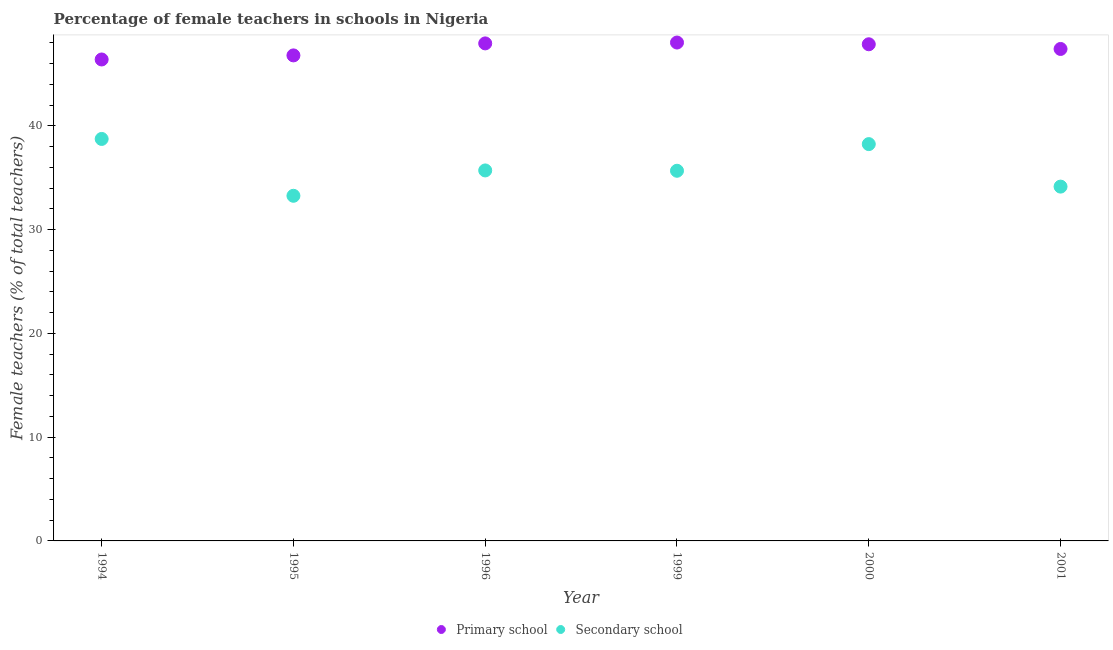How many different coloured dotlines are there?
Offer a very short reply. 2. What is the percentage of female teachers in primary schools in 1999?
Offer a terse response. 48.02. Across all years, what is the maximum percentage of female teachers in primary schools?
Your answer should be compact. 48.02. Across all years, what is the minimum percentage of female teachers in secondary schools?
Your answer should be very brief. 33.26. In which year was the percentage of female teachers in primary schools minimum?
Provide a short and direct response. 1994. What is the total percentage of female teachers in secondary schools in the graph?
Give a very brief answer. 215.74. What is the difference between the percentage of female teachers in secondary schools in 1995 and that in 2001?
Your response must be concise. -0.88. What is the difference between the percentage of female teachers in primary schools in 1999 and the percentage of female teachers in secondary schools in 2000?
Offer a very short reply. 9.79. What is the average percentage of female teachers in primary schools per year?
Your response must be concise. 47.4. In the year 2001, what is the difference between the percentage of female teachers in primary schools and percentage of female teachers in secondary schools?
Offer a terse response. 13.26. In how many years, is the percentage of female teachers in secondary schools greater than 2 %?
Keep it short and to the point. 6. What is the ratio of the percentage of female teachers in secondary schools in 1994 to that in 2000?
Ensure brevity in your answer.  1.01. Is the difference between the percentage of female teachers in primary schools in 1994 and 1995 greater than the difference between the percentage of female teachers in secondary schools in 1994 and 1995?
Your response must be concise. No. What is the difference between the highest and the second highest percentage of female teachers in secondary schools?
Offer a very short reply. 0.5. What is the difference between the highest and the lowest percentage of female teachers in primary schools?
Make the answer very short. 1.63. Is the sum of the percentage of female teachers in secondary schools in 1994 and 1995 greater than the maximum percentage of female teachers in primary schools across all years?
Provide a succinct answer. Yes. Does the percentage of female teachers in secondary schools monotonically increase over the years?
Provide a short and direct response. No. Is the percentage of female teachers in secondary schools strictly greater than the percentage of female teachers in primary schools over the years?
Offer a terse response. No. Is the percentage of female teachers in secondary schools strictly less than the percentage of female teachers in primary schools over the years?
Your answer should be compact. Yes. How many dotlines are there?
Your answer should be very brief. 2. What is the difference between two consecutive major ticks on the Y-axis?
Offer a very short reply. 10. Are the values on the major ticks of Y-axis written in scientific E-notation?
Offer a terse response. No. Does the graph contain any zero values?
Provide a succinct answer. No. Does the graph contain grids?
Keep it short and to the point. No. Where does the legend appear in the graph?
Make the answer very short. Bottom center. What is the title of the graph?
Give a very brief answer. Percentage of female teachers in schools in Nigeria. What is the label or title of the X-axis?
Your response must be concise. Year. What is the label or title of the Y-axis?
Provide a succinct answer. Female teachers (% of total teachers). What is the Female teachers (% of total teachers) of Primary school in 1994?
Make the answer very short. 46.39. What is the Female teachers (% of total teachers) of Secondary school in 1994?
Keep it short and to the point. 38.74. What is the Female teachers (% of total teachers) in Primary school in 1995?
Make the answer very short. 46.79. What is the Female teachers (% of total teachers) in Secondary school in 1995?
Offer a terse response. 33.26. What is the Female teachers (% of total teachers) in Primary school in 1996?
Offer a very short reply. 47.94. What is the Female teachers (% of total teachers) in Secondary school in 1996?
Give a very brief answer. 35.7. What is the Female teachers (% of total teachers) of Primary school in 1999?
Ensure brevity in your answer.  48.02. What is the Female teachers (% of total teachers) in Secondary school in 1999?
Offer a very short reply. 35.67. What is the Female teachers (% of total teachers) in Primary school in 2000?
Provide a short and direct response. 47.86. What is the Female teachers (% of total teachers) of Secondary school in 2000?
Provide a short and direct response. 38.24. What is the Female teachers (% of total teachers) in Primary school in 2001?
Give a very brief answer. 47.41. What is the Female teachers (% of total teachers) of Secondary school in 2001?
Provide a succinct answer. 34.14. Across all years, what is the maximum Female teachers (% of total teachers) in Primary school?
Ensure brevity in your answer.  48.02. Across all years, what is the maximum Female teachers (% of total teachers) in Secondary school?
Make the answer very short. 38.74. Across all years, what is the minimum Female teachers (% of total teachers) in Primary school?
Offer a terse response. 46.39. Across all years, what is the minimum Female teachers (% of total teachers) in Secondary school?
Offer a terse response. 33.26. What is the total Female teachers (% of total teachers) of Primary school in the graph?
Make the answer very short. 284.41. What is the total Female teachers (% of total teachers) in Secondary school in the graph?
Make the answer very short. 215.74. What is the difference between the Female teachers (% of total teachers) of Primary school in 1994 and that in 1995?
Keep it short and to the point. -0.39. What is the difference between the Female teachers (% of total teachers) in Secondary school in 1994 and that in 1995?
Your response must be concise. 5.48. What is the difference between the Female teachers (% of total teachers) of Primary school in 1994 and that in 1996?
Keep it short and to the point. -1.55. What is the difference between the Female teachers (% of total teachers) of Secondary school in 1994 and that in 1996?
Your answer should be compact. 3.03. What is the difference between the Female teachers (% of total teachers) of Primary school in 1994 and that in 1999?
Your answer should be compact. -1.63. What is the difference between the Female teachers (% of total teachers) of Secondary school in 1994 and that in 1999?
Offer a terse response. 3.07. What is the difference between the Female teachers (% of total teachers) in Primary school in 1994 and that in 2000?
Keep it short and to the point. -1.47. What is the difference between the Female teachers (% of total teachers) in Secondary school in 1994 and that in 2000?
Offer a very short reply. 0.5. What is the difference between the Female teachers (% of total teachers) in Primary school in 1994 and that in 2001?
Provide a short and direct response. -1.01. What is the difference between the Female teachers (% of total teachers) of Secondary school in 1994 and that in 2001?
Your answer should be compact. 4.59. What is the difference between the Female teachers (% of total teachers) of Primary school in 1995 and that in 1996?
Keep it short and to the point. -1.16. What is the difference between the Female teachers (% of total teachers) in Secondary school in 1995 and that in 1996?
Your response must be concise. -2.44. What is the difference between the Female teachers (% of total teachers) in Primary school in 1995 and that in 1999?
Offer a very short reply. -1.24. What is the difference between the Female teachers (% of total teachers) of Secondary school in 1995 and that in 1999?
Provide a short and direct response. -2.41. What is the difference between the Female teachers (% of total teachers) of Primary school in 1995 and that in 2000?
Keep it short and to the point. -1.07. What is the difference between the Female teachers (% of total teachers) in Secondary school in 1995 and that in 2000?
Provide a succinct answer. -4.98. What is the difference between the Female teachers (% of total teachers) in Primary school in 1995 and that in 2001?
Your answer should be very brief. -0.62. What is the difference between the Female teachers (% of total teachers) of Secondary school in 1995 and that in 2001?
Ensure brevity in your answer.  -0.88. What is the difference between the Female teachers (% of total teachers) in Primary school in 1996 and that in 1999?
Make the answer very short. -0.08. What is the difference between the Female teachers (% of total teachers) of Secondary school in 1996 and that in 1999?
Provide a short and direct response. 0.03. What is the difference between the Female teachers (% of total teachers) in Primary school in 1996 and that in 2000?
Your response must be concise. 0.08. What is the difference between the Female teachers (% of total teachers) of Secondary school in 1996 and that in 2000?
Your response must be concise. -2.54. What is the difference between the Female teachers (% of total teachers) in Primary school in 1996 and that in 2001?
Provide a succinct answer. 0.54. What is the difference between the Female teachers (% of total teachers) in Secondary school in 1996 and that in 2001?
Offer a terse response. 1.56. What is the difference between the Female teachers (% of total teachers) in Primary school in 1999 and that in 2000?
Provide a succinct answer. 0.17. What is the difference between the Female teachers (% of total teachers) of Secondary school in 1999 and that in 2000?
Your answer should be very brief. -2.57. What is the difference between the Female teachers (% of total teachers) in Primary school in 1999 and that in 2001?
Give a very brief answer. 0.62. What is the difference between the Female teachers (% of total teachers) in Secondary school in 1999 and that in 2001?
Your response must be concise. 1.53. What is the difference between the Female teachers (% of total teachers) of Primary school in 2000 and that in 2001?
Your answer should be very brief. 0.45. What is the difference between the Female teachers (% of total teachers) in Secondary school in 2000 and that in 2001?
Keep it short and to the point. 4.1. What is the difference between the Female teachers (% of total teachers) in Primary school in 1994 and the Female teachers (% of total teachers) in Secondary school in 1995?
Your response must be concise. 13.14. What is the difference between the Female teachers (% of total teachers) in Primary school in 1994 and the Female teachers (% of total teachers) in Secondary school in 1996?
Provide a short and direct response. 10.69. What is the difference between the Female teachers (% of total teachers) in Primary school in 1994 and the Female teachers (% of total teachers) in Secondary school in 1999?
Keep it short and to the point. 10.72. What is the difference between the Female teachers (% of total teachers) in Primary school in 1994 and the Female teachers (% of total teachers) in Secondary school in 2000?
Your answer should be very brief. 8.16. What is the difference between the Female teachers (% of total teachers) in Primary school in 1994 and the Female teachers (% of total teachers) in Secondary school in 2001?
Offer a very short reply. 12.25. What is the difference between the Female teachers (% of total teachers) in Primary school in 1995 and the Female teachers (% of total teachers) in Secondary school in 1996?
Your answer should be very brief. 11.09. What is the difference between the Female teachers (% of total teachers) in Primary school in 1995 and the Female teachers (% of total teachers) in Secondary school in 1999?
Provide a short and direct response. 11.12. What is the difference between the Female teachers (% of total teachers) in Primary school in 1995 and the Female teachers (% of total teachers) in Secondary school in 2000?
Your answer should be very brief. 8.55. What is the difference between the Female teachers (% of total teachers) of Primary school in 1995 and the Female teachers (% of total teachers) of Secondary school in 2001?
Your response must be concise. 12.64. What is the difference between the Female teachers (% of total teachers) in Primary school in 1996 and the Female teachers (% of total teachers) in Secondary school in 1999?
Provide a succinct answer. 12.27. What is the difference between the Female teachers (% of total teachers) in Primary school in 1996 and the Female teachers (% of total teachers) in Secondary school in 2000?
Your answer should be very brief. 9.71. What is the difference between the Female teachers (% of total teachers) in Primary school in 1996 and the Female teachers (% of total teachers) in Secondary school in 2001?
Ensure brevity in your answer.  13.8. What is the difference between the Female teachers (% of total teachers) in Primary school in 1999 and the Female teachers (% of total teachers) in Secondary school in 2000?
Give a very brief answer. 9.79. What is the difference between the Female teachers (% of total teachers) of Primary school in 1999 and the Female teachers (% of total teachers) of Secondary school in 2001?
Your answer should be very brief. 13.88. What is the difference between the Female teachers (% of total teachers) of Primary school in 2000 and the Female teachers (% of total teachers) of Secondary school in 2001?
Your answer should be very brief. 13.72. What is the average Female teachers (% of total teachers) in Primary school per year?
Provide a succinct answer. 47.4. What is the average Female teachers (% of total teachers) of Secondary school per year?
Provide a succinct answer. 35.96. In the year 1994, what is the difference between the Female teachers (% of total teachers) in Primary school and Female teachers (% of total teachers) in Secondary school?
Your response must be concise. 7.66. In the year 1995, what is the difference between the Female teachers (% of total teachers) of Primary school and Female teachers (% of total teachers) of Secondary school?
Provide a succinct answer. 13.53. In the year 1996, what is the difference between the Female teachers (% of total teachers) of Primary school and Female teachers (% of total teachers) of Secondary school?
Keep it short and to the point. 12.24. In the year 1999, what is the difference between the Female teachers (% of total teachers) of Primary school and Female teachers (% of total teachers) of Secondary school?
Provide a short and direct response. 12.36. In the year 2000, what is the difference between the Female teachers (% of total teachers) of Primary school and Female teachers (% of total teachers) of Secondary school?
Make the answer very short. 9.62. In the year 2001, what is the difference between the Female teachers (% of total teachers) of Primary school and Female teachers (% of total teachers) of Secondary school?
Offer a very short reply. 13.26. What is the ratio of the Female teachers (% of total teachers) in Primary school in 1994 to that in 1995?
Your response must be concise. 0.99. What is the ratio of the Female teachers (% of total teachers) of Secondary school in 1994 to that in 1995?
Your answer should be very brief. 1.16. What is the ratio of the Female teachers (% of total teachers) in Secondary school in 1994 to that in 1996?
Give a very brief answer. 1.08. What is the ratio of the Female teachers (% of total teachers) of Secondary school in 1994 to that in 1999?
Ensure brevity in your answer.  1.09. What is the ratio of the Female teachers (% of total teachers) in Primary school in 1994 to that in 2000?
Offer a very short reply. 0.97. What is the ratio of the Female teachers (% of total teachers) in Primary school in 1994 to that in 2001?
Keep it short and to the point. 0.98. What is the ratio of the Female teachers (% of total teachers) in Secondary school in 1994 to that in 2001?
Offer a very short reply. 1.13. What is the ratio of the Female teachers (% of total teachers) in Primary school in 1995 to that in 1996?
Keep it short and to the point. 0.98. What is the ratio of the Female teachers (% of total teachers) of Secondary school in 1995 to that in 1996?
Your answer should be compact. 0.93. What is the ratio of the Female teachers (% of total teachers) of Primary school in 1995 to that in 1999?
Provide a succinct answer. 0.97. What is the ratio of the Female teachers (% of total teachers) of Secondary school in 1995 to that in 1999?
Give a very brief answer. 0.93. What is the ratio of the Female teachers (% of total teachers) of Primary school in 1995 to that in 2000?
Your answer should be very brief. 0.98. What is the ratio of the Female teachers (% of total teachers) in Secondary school in 1995 to that in 2000?
Your response must be concise. 0.87. What is the ratio of the Female teachers (% of total teachers) in Primary school in 1995 to that in 2001?
Keep it short and to the point. 0.99. What is the ratio of the Female teachers (% of total teachers) in Secondary school in 1995 to that in 2001?
Give a very brief answer. 0.97. What is the ratio of the Female teachers (% of total teachers) of Secondary school in 1996 to that in 1999?
Make the answer very short. 1. What is the ratio of the Female teachers (% of total teachers) of Secondary school in 1996 to that in 2000?
Offer a terse response. 0.93. What is the ratio of the Female teachers (% of total teachers) of Primary school in 1996 to that in 2001?
Ensure brevity in your answer.  1.01. What is the ratio of the Female teachers (% of total teachers) of Secondary school in 1996 to that in 2001?
Your answer should be very brief. 1.05. What is the ratio of the Female teachers (% of total teachers) of Primary school in 1999 to that in 2000?
Your answer should be compact. 1. What is the ratio of the Female teachers (% of total teachers) of Secondary school in 1999 to that in 2000?
Offer a terse response. 0.93. What is the ratio of the Female teachers (% of total teachers) of Primary school in 1999 to that in 2001?
Make the answer very short. 1.01. What is the ratio of the Female teachers (% of total teachers) in Secondary school in 1999 to that in 2001?
Give a very brief answer. 1.04. What is the ratio of the Female teachers (% of total teachers) of Primary school in 2000 to that in 2001?
Keep it short and to the point. 1.01. What is the ratio of the Female teachers (% of total teachers) in Secondary school in 2000 to that in 2001?
Your answer should be very brief. 1.12. What is the difference between the highest and the second highest Female teachers (% of total teachers) in Primary school?
Give a very brief answer. 0.08. What is the difference between the highest and the second highest Female teachers (% of total teachers) in Secondary school?
Offer a very short reply. 0.5. What is the difference between the highest and the lowest Female teachers (% of total teachers) of Primary school?
Your response must be concise. 1.63. What is the difference between the highest and the lowest Female teachers (% of total teachers) of Secondary school?
Offer a very short reply. 5.48. 